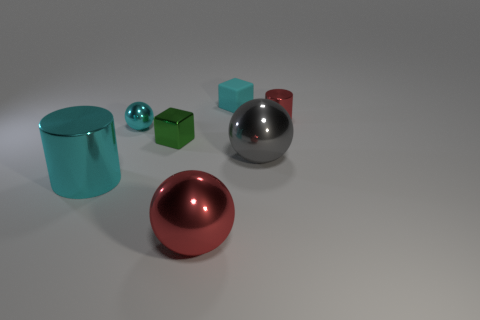Does the small rubber object have the same color as the large cylinder?
Your answer should be very brief. Yes. Is there another cyan ball of the same size as the cyan metal sphere?
Make the answer very short. No. Are there fewer small things in front of the large gray ball than shiny cylinders?
Ensure brevity in your answer.  Yes. Are there fewer large red balls that are in front of the small matte object than shiny cylinders that are in front of the large red object?
Give a very brief answer. No. How many cylinders are either red shiny things or large metal things?
Provide a short and direct response. 2. Is the material of the big ball that is left of the tiny cyan matte object the same as the tiny block in front of the cyan matte cube?
Your response must be concise. Yes. There is a red metallic thing that is the same size as the cyan cube; what shape is it?
Offer a very short reply. Cylinder. What number of other objects are the same color as the big cylinder?
Your answer should be very brief. 2. What number of red things are small cylinders or tiny spheres?
Give a very brief answer. 1. Does the red metallic thing right of the big gray ball have the same shape as the cyan object behind the tiny red metal object?
Give a very brief answer. No. 